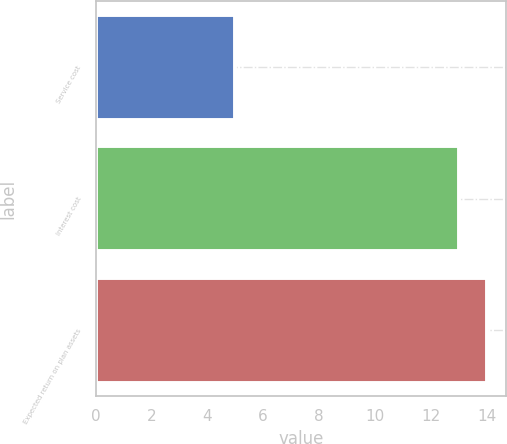Convert chart. <chart><loc_0><loc_0><loc_500><loc_500><bar_chart><fcel>Service cost<fcel>Interest cost<fcel>Expected return on plan assets<nl><fcel>5<fcel>13<fcel>14<nl></chart> 